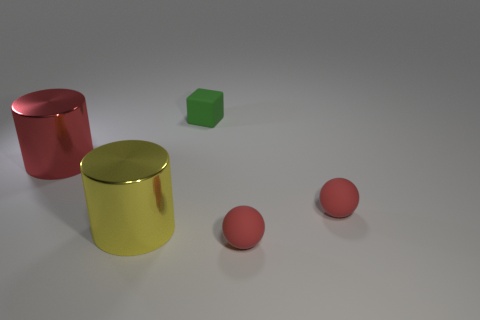What material is the big yellow object?
Provide a short and direct response. Metal. Are there fewer red rubber things behind the tiny rubber cube than red balls?
Offer a very short reply. Yes. There is a big metal object that is left of the yellow metallic object; what color is it?
Your answer should be very brief. Red. There is a red metallic thing; what shape is it?
Give a very brief answer. Cylinder. Are there any small balls that are in front of the small matte sphere that is right of the red rubber sphere that is in front of the yellow object?
Your response must be concise. Yes. There is a rubber object that is behind the red object to the left of the tiny green cube that is behind the red metal thing; what color is it?
Ensure brevity in your answer.  Green. What material is the other object that is the same shape as the large red thing?
Your answer should be very brief. Metal. What is the size of the object that is behind the red object that is on the left side of the tiny green matte object?
Your answer should be compact. Small. What is the material of the red object on the left side of the small rubber block?
Offer a very short reply. Metal. The red cylinder that is the same material as the yellow thing is what size?
Make the answer very short. Large. 